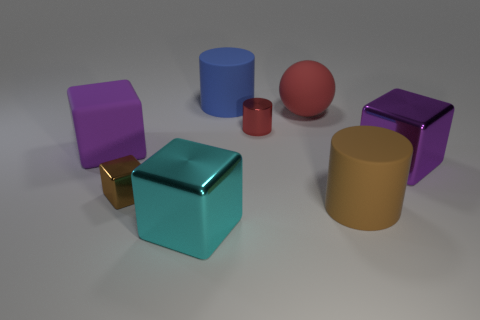What number of shiny things are in front of the small red cylinder and behind the cyan shiny cube?
Provide a short and direct response. 2. There is a brown cube that is the same size as the red shiny thing; what is it made of?
Offer a very short reply. Metal. Do the brown object that is behind the brown cylinder and the red ball that is left of the large purple metallic cube have the same size?
Provide a short and direct response. No. There is a blue object; are there any big shiny things to the right of it?
Provide a succinct answer. Yes. What color is the rubber object that is behind the large matte sphere that is behind the large brown rubber cylinder?
Offer a very short reply. Blue. Are there fewer matte cubes than brown spheres?
Provide a short and direct response. No. What number of other things are the same shape as the red metallic object?
Offer a very short reply. 2. There is a cube that is the same size as the red shiny cylinder; what color is it?
Provide a succinct answer. Brown. Is the number of metallic cylinders that are behind the big ball the same as the number of large blue rubber objects that are in front of the small metal block?
Offer a very short reply. Yes. Are there any red things that have the same size as the brown cube?
Give a very brief answer. Yes. 